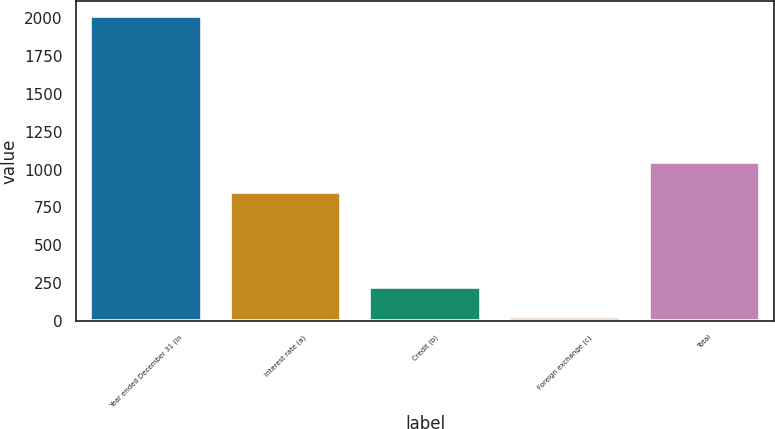<chart> <loc_0><loc_0><loc_500><loc_500><bar_chart><fcel>Year ended December 31 (in<fcel>Interest rate (a)<fcel>Credit (b)<fcel>Foreign exchange (c)<fcel>Total<nl><fcel>2015<fcel>853<fcel>224<fcel>25<fcel>1052<nl></chart> 